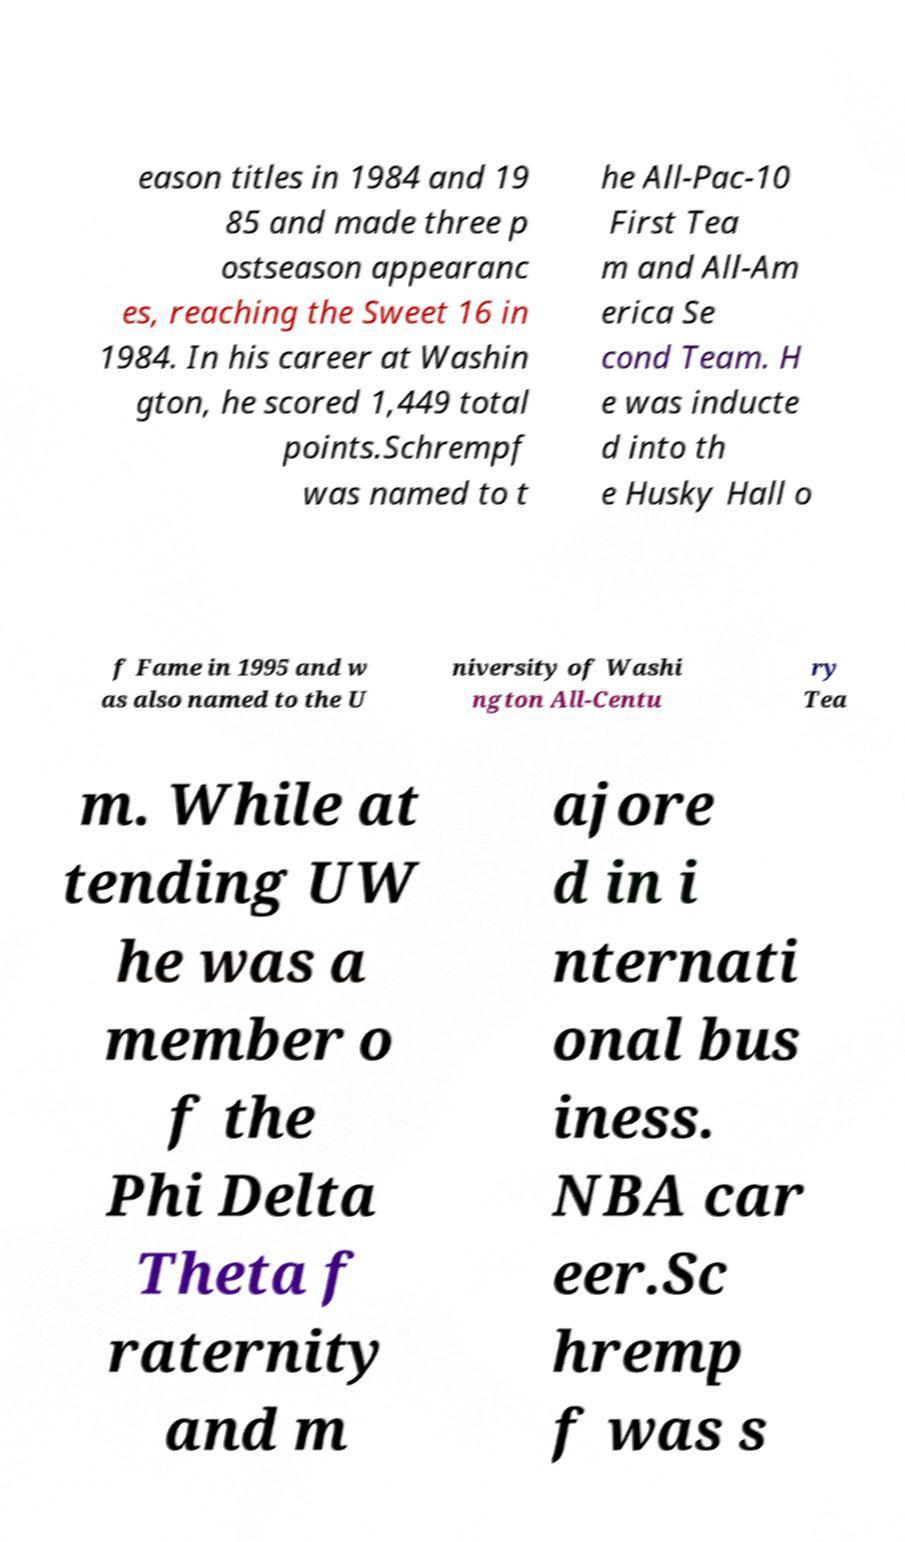I need the written content from this picture converted into text. Can you do that? eason titles in 1984 and 19 85 and made three p ostseason appearanc es, reaching the Sweet 16 in 1984. In his career at Washin gton, he scored 1,449 total points.Schrempf was named to t he All-Pac-10 First Tea m and All-Am erica Se cond Team. H e was inducte d into th e Husky Hall o f Fame in 1995 and w as also named to the U niversity of Washi ngton All-Centu ry Tea m. While at tending UW he was a member o f the Phi Delta Theta f raternity and m ajore d in i nternati onal bus iness. NBA car eer.Sc hremp f was s 